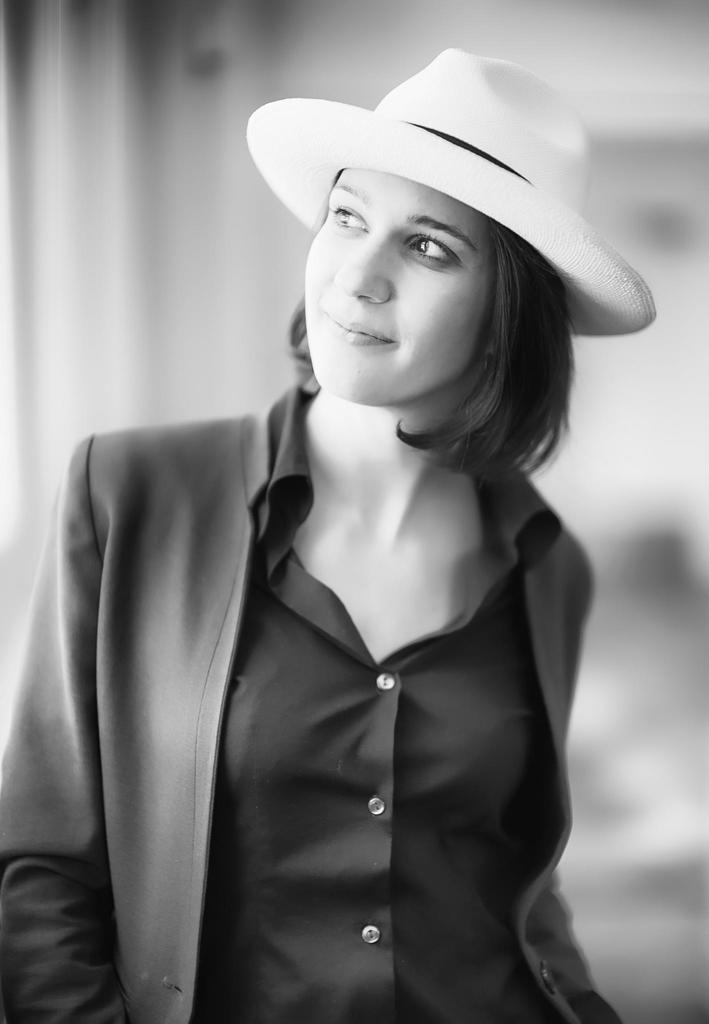Who or what is the main subject of the image? There is a person in the image. Can you describe the background of the image? The background of the image is blurred. What can be observed about the person's attire in the image? The person is wearing clothes. What type of headwear is the person wearing in the image? The person is wearing a hat. How many bulbs are visible on the person's hat in the image? There are no bulbs visible on the person's hat in the image. What type of cushion is the person sitting on in the image? There is no cushion present in the image, and the person is not sitting down. 